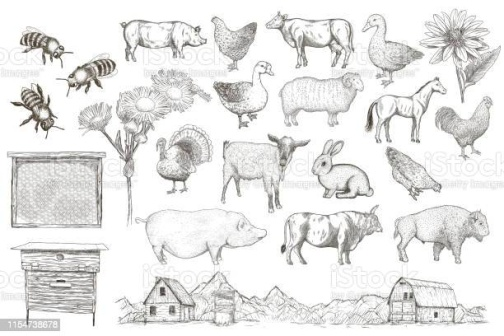Write a detailed description of the given image. The image showcases a monochromatic collection of finely detailed sketches, each artfully capturing the essence of farm life. These sketches are organized in a three-row and six-column grid, creating a visually harmonious arrangement.

In the top row, starting from the left, we encounter a bee in mid-flight, immediately followed by a cow standing tall with its distinctive spots. Next is a chicken pecking at the ground, a pig wallowing contentedly, a fluffy sheep grazing, and a goose with its wings spread wide.

The middle row begins with a grand sunflower, its petals radiating outwards in a captivating display. Beside it is a rabbit sitting alert on its hind legs, ears perked upward. This is followed by another pig in a different pose, a cow facing the opposite direction compared to the one in the top row, a rooster in the midst of crowing, and another distinct sheep.

In the bottom row, we start with a beehive hanging from a branch. Following this is yet another uniquely posed pig, a sturdy barn representing the heart of the farmstead, a serene mountain range stretching across the background, and, finally, a single blooming flower at the end of the row.

While the sketches are simple in color, their detailed execution effectively brings to life the vibrant and bustling world of a farm. 